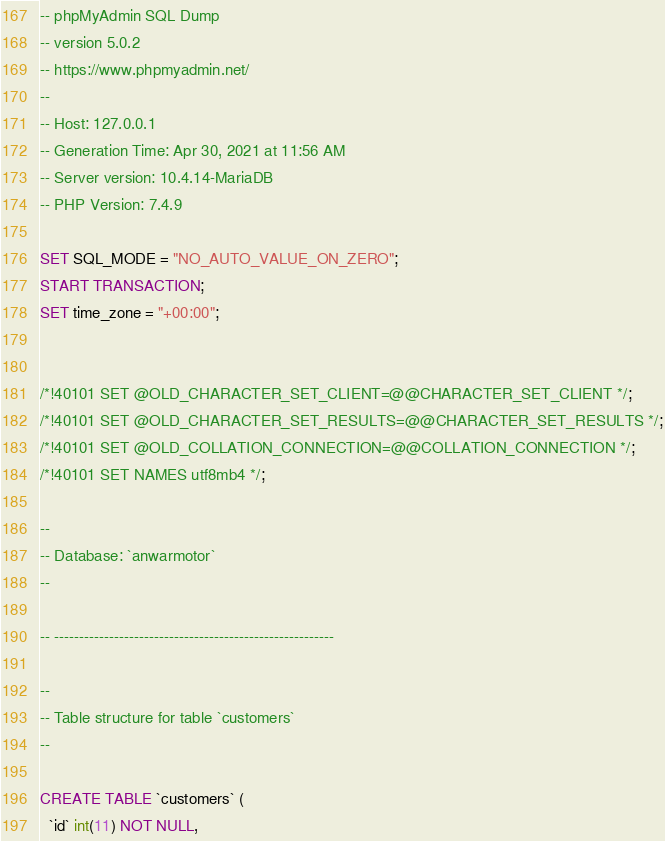Convert code to text. <code><loc_0><loc_0><loc_500><loc_500><_SQL_>-- phpMyAdmin SQL Dump
-- version 5.0.2
-- https://www.phpmyadmin.net/
--
-- Host: 127.0.0.1
-- Generation Time: Apr 30, 2021 at 11:56 AM
-- Server version: 10.4.14-MariaDB
-- PHP Version: 7.4.9

SET SQL_MODE = "NO_AUTO_VALUE_ON_ZERO";
START TRANSACTION;
SET time_zone = "+00:00";


/*!40101 SET @OLD_CHARACTER_SET_CLIENT=@@CHARACTER_SET_CLIENT */;
/*!40101 SET @OLD_CHARACTER_SET_RESULTS=@@CHARACTER_SET_RESULTS */;
/*!40101 SET @OLD_COLLATION_CONNECTION=@@COLLATION_CONNECTION */;
/*!40101 SET NAMES utf8mb4 */;

--
-- Database: `anwarmotor`
--

-- --------------------------------------------------------

--
-- Table structure for table `customers`
--

CREATE TABLE `customers` (
  `id` int(11) NOT NULL,</code> 